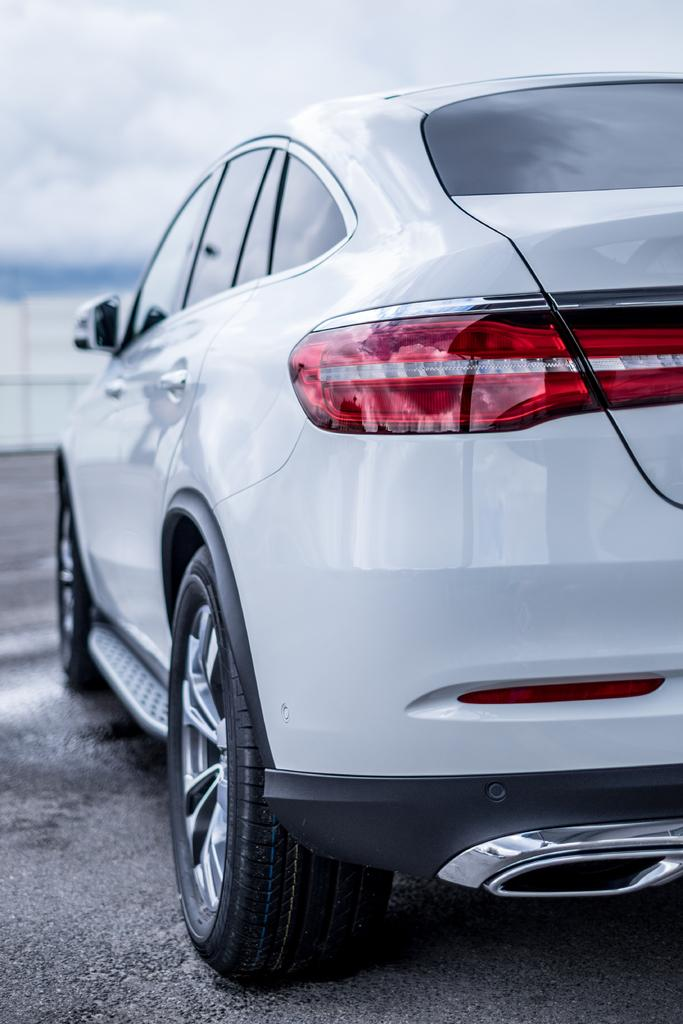What is the main subject of the image? The main subject of the image is a car. Can you describe the car in the image? The car is white. What can be seen in the background of the image? There is sky visible in the background of the image. What is at the bottom of the image? There is a road at the bottom of the image. How many sisters are sitting in the car in the image? There are no sisters present in the image; it only features a car. What type of toothbrush is visible in the image? There is no toothbrush present in the image. 